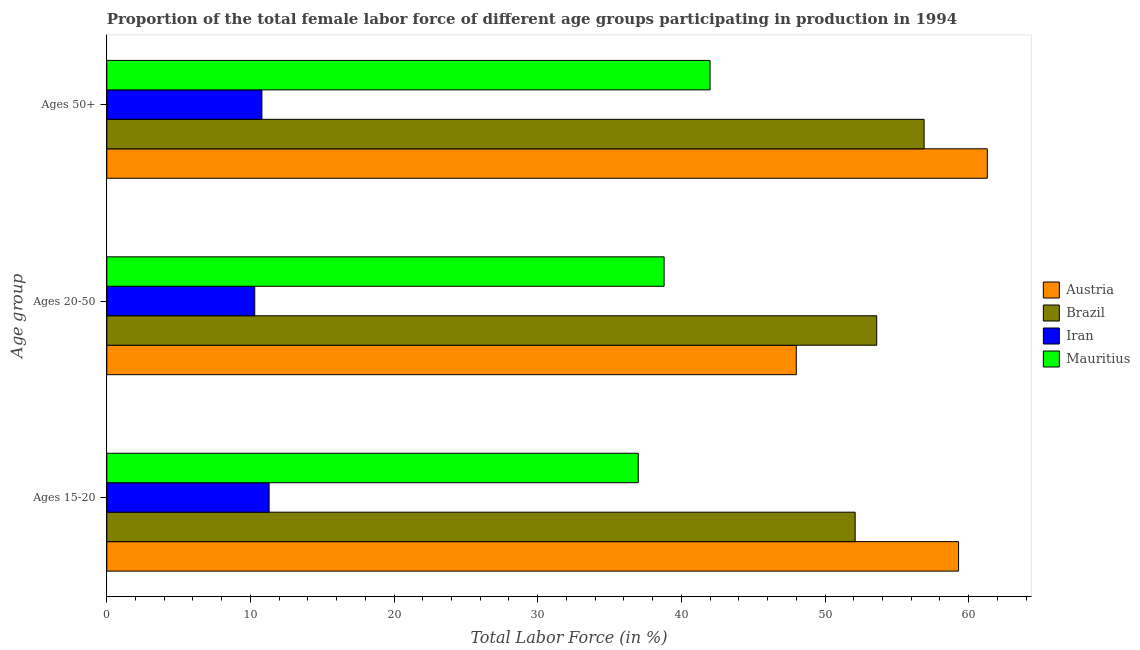How many groups of bars are there?
Ensure brevity in your answer.  3. Are the number of bars on each tick of the Y-axis equal?
Your answer should be very brief. Yes. What is the label of the 1st group of bars from the top?
Your response must be concise. Ages 50+. What is the percentage of female labor force above age 50 in Iran?
Your response must be concise. 10.8. Across all countries, what is the maximum percentage of female labor force above age 50?
Give a very brief answer. 61.3. Across all countries, what is the minimum percentage of female labor force above age 50?
Keep it short and to the point. 10.8. In which country was the percentage of female labor force within the age group 15-20 maximum?
Provide a succinct answer. Austria. In which country was the percentage of female labor force within the age group 20-50 minimum?
Provide a short and direct response. Iran. What is the total percentage of female labor force within the age group 20-50 in the graph?
Make the answer very short. 150.7. What is the difference between the percentage of female labor force above age 50 in Brazil and that in Austria?
Keep it short and to the point. -4.4. What is the difference between the percentage of female labor force within the age group 15-20 in Iran and the percentage of female labor force within the age group 20-50 in Austria?
Ensure brevity in your answer.  -36.7. What is the average percentage of female labor force within the age group 20-50 per country?
Provide a succinct answer. 37.67. What is the difference between the percentage of female labor force within the age group 20-50 and percentage of female labor force within the age group 15-20 in Austria?
Provide a short and direct response. -11.3. What is the ratio of the percentage of female labor force within the age group 15-20 in Austria to that in Iran?
Provide a short and direct response. 5.25. Is the percentage of female labor force within the age group 15-20 in Brazil less than that in Iran?
Your response must be concise. No. What is the difference between the highest and the second highest percentage of female labor force above age 50?
Your answer should be compact. 4.4. What is the difference between the highest and the lowest percentage of female labor force above age 50?
Keep it short and to the point. 50.5. In how many countries, is the percentage of female labor force within the age group 20-50 greater than the average percentage of female labor force within the age group 20-50 taken over all countries?
Offer a terse response. 3. What does the 3rd bar from the top in Ages 50+ represents?
Make the answer very short. Brazil. Is it the case that in every country, the sum of the percentage of female labor force within the age group 15-20 and percentage of female labor force within the age group 20-50 is greater than the percentage of female labor force above age 50?
Make the answer very short. Yes. How many bars are there?
Your answer should be very brief. 12. How many countries are there in the graph?
Provide a succinct answer. 4. Are the values on the major ticks of X-axis written in scientific E-notation?
Make the answer very short. No. Where does the legend appear in the graph?
Keep it short and to the point. Center right. How are the legend labels stacked?
Provide a short and direct response. Vertical. What is the title of the graph?
Give a very brief answer. Proportion of the total female labor force of different age groups participating in production in 1994. What is the label or title of the Y-axis?
Give a very brief answer. Age group. What is the Total Labor Force (in %) in Austria in Ages 15-20?
Your response must be concise. 59.3. What is the Total Labor Force (in %) in Brazil in Ages 15-20?
Your answer should be very brief. 52.1. What is the Total Labor Force (in %) in Iran in Ages 15-20?
Provide a short and direct response. 11.3. What is the Total Labor Force (in %) in Mauritius in Ages 15-20?
Give a very brief answer. 37. What is the Total Labor Force (in %) in Brazil in Ages 20-50?
Give a very brief answer. 53.6. What is the Total Labor Force (in %) in Iran in Ages 20-50?
Your response must be concise. 10.3. What is the Total Labor Force (in %) of Mauritius in Ages 20-50?
Offer a terse response. 38.8. What is the Total Labor Force (in %) of Austria in Ages 50+?
Provide a short and direct response. 61.3. What is the Total Labor Force (in %) in Brazil in Ages 50+?
Your response must be concise. 56.9. What is the Total Labor Force (in %) of Iran in Ages 50+?
Provide a short and direct response. 10.8. What is the Total Labor Force (in %) in Mauritius in Ages 50+?
Your response must be concise. 42. Across all Age group, what is the maximum Total Labor Force (in %) in Austria?
Make the answer very short. 61.3. Across all Age group, what is the maximum Total Labor Force (in %) of Brazil?
Your answer should be very brief. 56.9. Across all Age group, what is the maximum Total Labor Force (in %) in Iran?
Provide a succinct answer. 11.3. Across all Age group, what is the minimum Total Labor Force (in %) in Brazil?
Your response must be concise. 52.1. Across all Age group, what is the minimum Total Labor Force (in %) of Iran?
Offer a terse response. 10.3. Across all Age group, what is the minimum Total Labor Force (in %) of Mauritius?
Provide a succinct answer. 37. What is the total Total Labor Force (in %) in Austria in the graph?
Your response must be concise. 168.6. What is the total Total Labor Force (in %) in Brazil in the graph?
Provide a succinct answer. 162.6. What is the total Total Labor Force (in %) in Iran in the graph?
Keep it short and to the point. 32.4. What is the total Total Labor Force (in %) of Mauritius in the graph?
Give a very brief answer. 117.8. What is the difference between the Total Labor Force (in %) of Brazil in Ages 15-20 and that in Ages 20-50?
Provide a succinct answer. -1.5. What is the difference between the Total Labor Force (in %) of Iran in Ages 15-20 and that in Ages 20-50?
Your response must be concise. 1. What is the difference between the Total Labor Force (in %) in Mauritius in Ages 15-20 and that in Ages 20-50?
Give a very brief answer. -1.8. What is the difference between the Total Labor Force (in %) in Austria in Ages 15-20 and that in Ages 50+?
Offer a terse response. -2. What is the difference between the Total Labor Force (in %) of Brazil in Ages 15-20 and that in Ages 50+?
Keep it short and to the point. -4.8. What is the difference between the Total Labor Force (in %) of Mauritius in Ages 15-20 and that in Ages 50+?
Offer a terse response. -5. What is the difference between the Total Labor Force (in %) of Austria in Ages 20-50 and that in Ages 50+?
Your answer should be very brief. -13.3. What is the difference between the Total Labor Force (in %) in Austria in Ages 15-20 and the Total Labor Force (in %) in Iran in Ages 20-50?
Offer a terse response. 49. What is the difference between the Total Labor Force (in %) in Austria in Ages 15-20 and the Total Labor Force (in %) in Mauritius in Ages 20-50?
Offer a very short reply. 20.5. What is the difference between the Total Labor Force (in %) of Brazil in Ages 15-20 and the Total Labor Force (in %) of Iran in Ages 20-50?
Your answer should be compact. 41.8. What is the difference between the Total Labor Force (in %) in Brazil in Ages 15-20 and the Total Labor Force (in %) in Mauritius in Ages 20-50?
Offer a very short reply. 13.3. What is the difference between the Total Labor Force (in %) in Iran in Ages 15-20 and the Total Labor Force (in %) in Mauritius in Ages 20-50?
Your answer should be very brief. -27.5. What is the difference between the Total Labor Force (in %) of Austria in Ages 15-20 and the Total Labor Force (in %) of Iran in Ages 50+?
Keep it short and to the point. 48.5. What is the difference between the Total Labor Force (in %) in Austria in Ages 15-20 and the Total Labor Force (in %) in Mauritius in Ages 50+?
Offer a very short reply. 17.3. What is the difference between the Total Labor Force (in %) in Brazil in Ages 15-20 and the Total Labor Force (in %) in Iran in Ages 50+?
Make the answer very short. 41.3. What is the difference between the Total Labor Force (in %) in Brazil in Ages 15-20 and the Total Labor Force (in %) in Mauritius in Ages 50+?
Keep it short and to the point. 10.1. What is the difference between the Total Labor Force (in %) in Iran in Ages 15-20 and the Total Labor Force (in %) in Mauritius in Ages 50+?
Give a very brief answer. -30.7. What is the difference between the Total Labor Force (in %) of Austria in Ages 20-50 and the Total Labor Force (in %) of Iran in Ages 50+?
Provide a short and direct response. 37.2. What is the difference between the Total Labor Force (in %) in Austria in Ages 20-50 and the Total Labor Force (in %) in Mauritius in Ages 50+?
Keep it short and to the point. 6. What is the difference between the Total Labor Force (in %) in Brazil in Ages 20-50 and the Total Labor Force (in %) in Iran in Ages 50+?
Make the answer very short. 42.8. What is the difference between the Total Labor Force (in %) of Brazil in Ages 20-50 and the Total Labor Force (in %) of Mauritius in Ages 50+?
Offer a very short reply. 11.6. What is the difference between the Total Labor Force (in %) of Iran in Ages 20-50 and the Total Labor Force (in %) of Mauritius in Ages 50+?
Make the answer very short. -31.7. What is the average Total Labor Force (in %) of Austria per Age group?
Ensure brevity in your answer.  56.2. What is the average Total Labor Force (in %) of Brazil per Age group?
Keep it short and to the point. 54.2. What is the average Total Labor Force (in %) of Mauritius per Age group?
Provide a short and direct response. 39.27. What is the difference between the Total Labor Force (in %) in Austria and Total Labor Force (in %) in Brazil in Ages 15-20?
Provide a short and direct response. 7.2. What is the difference between the Total Labor Force (in %) of Austria and Total Labor Force (in %) of Iran in Ages 15-20?
Provide a succinct answer. 48. What is the difference between the Total Labor Force (in %) in Austria and Total Labor Force (in %) in Mauritius in Ages 15-20?
Your answer should be compact. 22.3. What is the difference between the Total Labor Force (in %) in Brazil and Total Labor Force (in %) in Iran in Ages 15-20?
Offer a very short reply. 40.8. What is the difference between the Total Labor Force (in %) of Brazil and Total Labor Force (in %) of Mauritius in Ages 15-20?
Make the answer very short. 15.1. What is the difference between the Total Labor Force (in %) of Iran and Total Labor Force (in %) of Mauritius in Ages 15-20?
Make the answer very short. -25.7. What is the difference between the Total Labor Force (in %) of Austria and Total Labor Force (in %) of Iran in Ages 20-50?
Your answer should be compact. 37.7. What is the difference between the Total Labor Force (in %) in Austria and Total Labor Force (in %) in Mauritius in Ages 20-50?
Offer a terse response. 9.2. What is the difference between the Total Labor Force (in %) of Brazil and Total Labor Force (in %) of Iran in Ages 20-50?
Make the answer very short. 43.3. What is the difference between the Total Labor Force (in %) of Brazil and Total Labor Force (in %) of Mauritius in Ages 20-50?
Your answer should be very brief. 14.8. What is the difference between the Total Labor Force (in %) of Iran and Total Labor Force (in %) of Mauritius in Ages 20-50?
Your response must be concise. -28.5. What is the difference between the Total Labor Force (in %) of Austria and Total Labor Force (in %) of Iran in Ages 50+?
Give a very brief answer. 50.5. What is the difference between the Total Labor Force (in %) of Austria and Total Labor Force (in %) of Mauritius in Ages 50+?
Offer a terse response. 19.3. What is the difference between the Total Labor Force (in %) in Brazil and Total Labor Force (in %) in Iran in Ages 50+?
Give a very brief answer. 46.1. What is the difference between the Total Labor Force (in %) of Iran and Total Labor Force (in %) of Mauritius in Ages 50+?
Offer a very short reply. -31.2. What is the ratio of the Total Labor Force (in %) of Austria in Ages 15-20 to that in Ages 20-50?
Your answer should be very brief. 1.24. What is the ratio of the Total Labor Force (in %) in Brazil in Ages 15-20 to that in Ages 20-50?
Offer a very short reply. 0.97. What is the ratio of the Total Labor Force (in %) in Iran in Ages 15-20 to that in Ages 20-50?
Your answer should be very brief. 1.1. What is the ratio of the Total Labor Force (in %) of Mauritius in Ages 15-20 to that in Ages 20-50?
Keep it short and to the point. 0.95. What is the ratio of the Total Labor Force (in %) of Austria in Ages 15-20 to that in Ages 50+?
Provide a short and direct response. 0.97. What is the ratio of the Total Labor Force (in %) of Brazil in Ages 15-20 to that in Ages 50+?
Provide a short and direct response. 0.92. What is the ratio of the Total Labor Force (in %) of Iran in Ages 15-20 to that in Ages 50+?
Your answer should be very brief. 1.05. What is the ratio of the Total Labor Force (in %) in Mauritius in Ages 15-20 to that in Ages 50+?
Ensure brevity in your answer.  0.88. What is the ratio of the Total Labor Force (in %) of Austria in Ages 20-50 to that in Ages 50+?
Give a very brief answer. 0.78. What is the ratio of the Total Labor Force (in %) in Brazil in Ages 20-50 to that in Ages 50+?
Ensure brevity in your answer.  0.94. What is the ratio of the Total Labor Force (in %) of Iran in Ages 20-50 to that in Ages 50+?
Give a very brief answer. 0.95. What is the ratio of the Total Labor Force (in %) of Mauritius in Ages 20-50 to that in Ages 50+?
Make the answer very short. 0.92. What is the difference between the highest and the second highest Total Labor Force (in %) in Austria?
Give a very brief answer. 2. What is the difference between the highest and the second highest Total Labor Force (in %) in Iran?
Your response must be concise. 0.5. What is the difference between the highest and the lowest Total Labor Force (in %) of Brazil?
Your response must be concise. 4.8. What is the difference between the highest and the lowest Total Labor Force (in %) of Iran?
Provide a short and direct response. 1. What is the difference between the highest and the lowest Total Labor Force (in %) in Mauritius?
Ensure brevity in your answer.  5. 